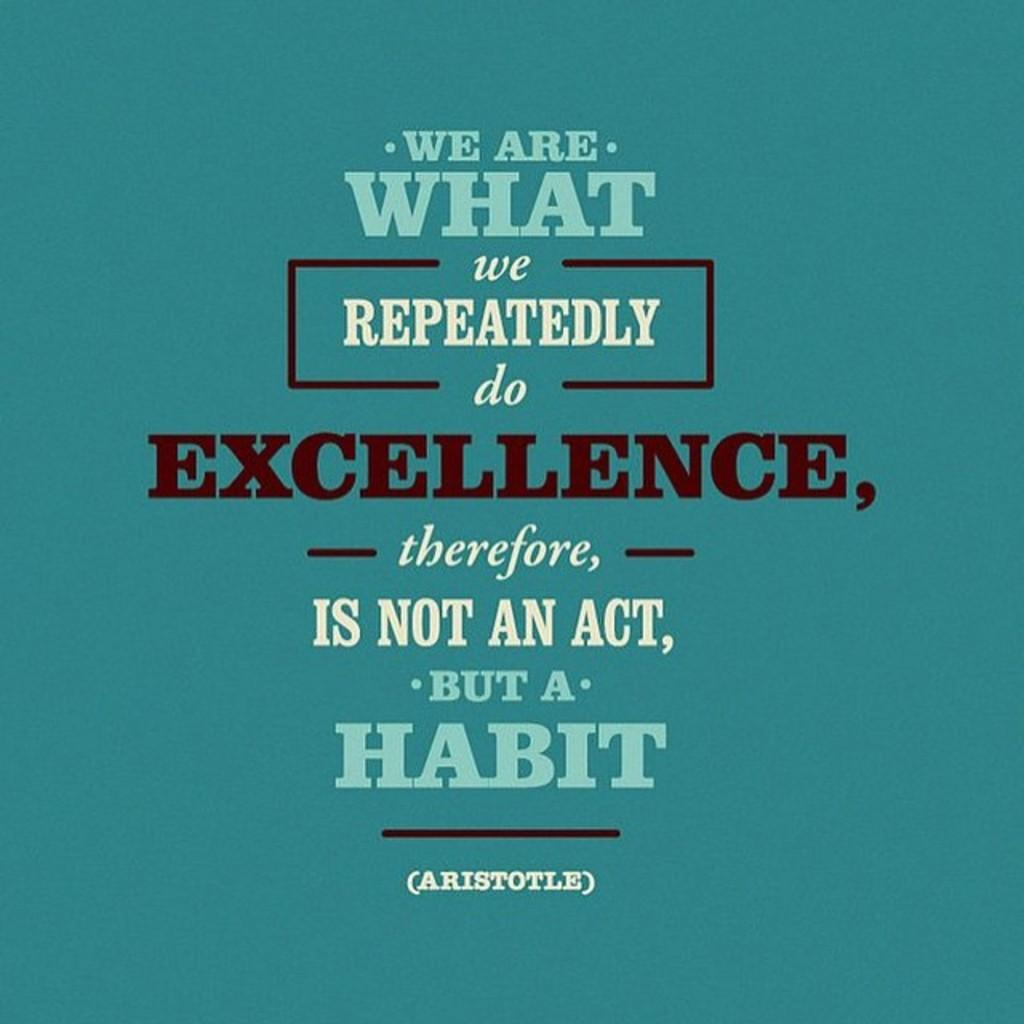<image>
Render a clear and concise summary of the photo. A blue poster with a quote from aristotle on it. 